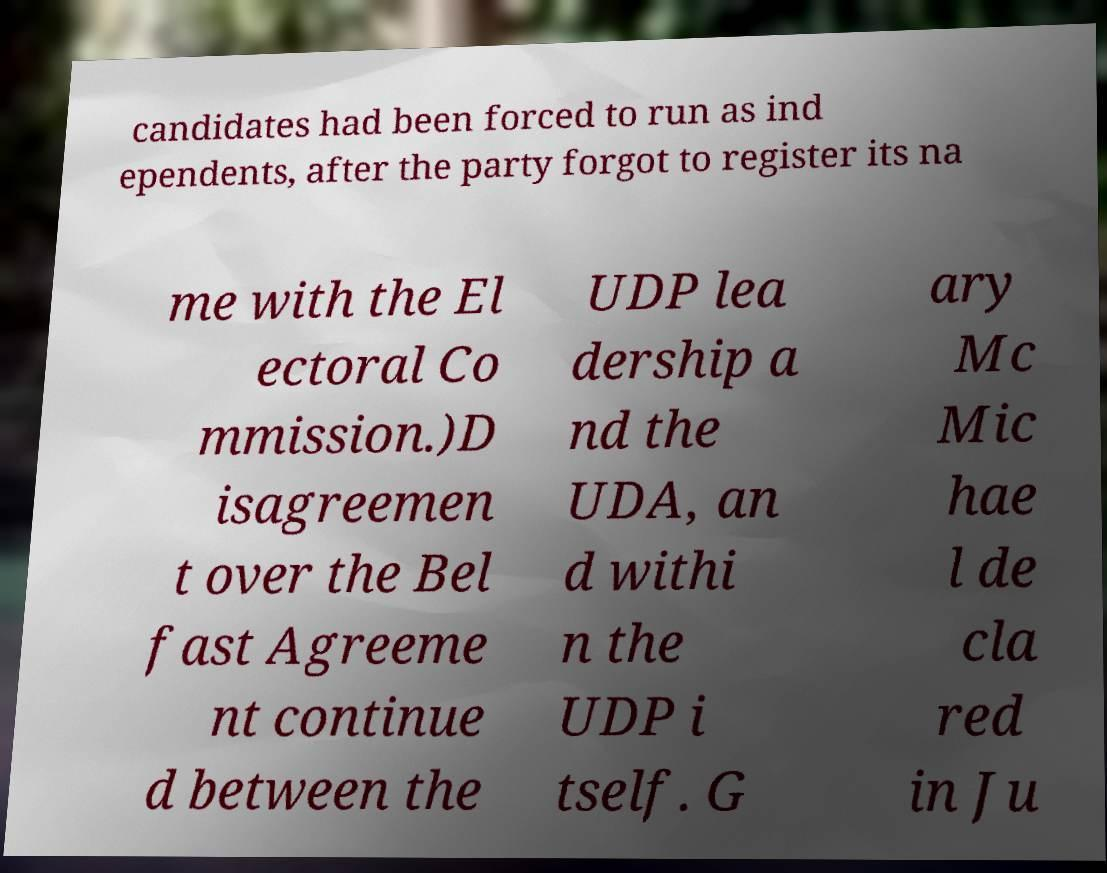Could you assist in decoding the text presented in this image and type it out clearly? candidates had been forced to run as ind ependents, after the party forgot to register its na me with the El ectoral Co mmission.)D isagreemen t over the Bel fast Agreeme nt continue d between the UDP lea dership a nd the UDA, an d withi n the UDP i tself. G ary Mc Mic hae l de cla red in Ju 